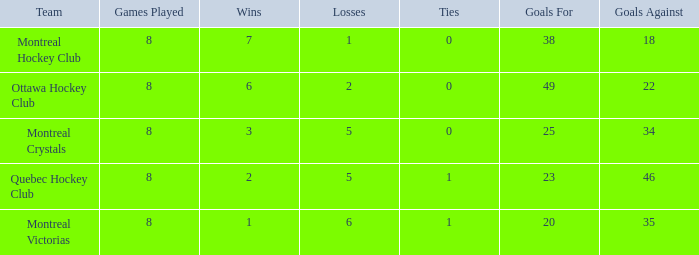What is the standard ties when the team is montreal victorias and the games played is over 8? None. 